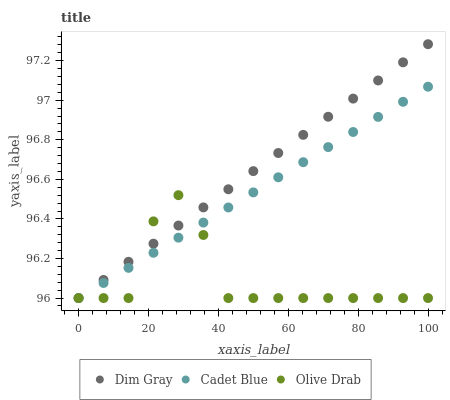Does Olive Drab have the minimum area under the curve?
Answer yes or no. Yes. Does Dim Gray have the maximum area under the curve?
Answer yes or no. Yes. Does Dim Gray have the minimum area under the curve?
Answer yes or no. No. Does Olive Drab have the maximum area under the curve?
Answer yes or no. No. Is Dim Gray the smoothest?
Answer yes or no. Yes. Is Olive Drab the roughest?
Answer yes or no. Yes. Is Olive Drab the smoothest?
Answer yes or no. No. Is Dim Gray the roughest?
Answer yes or no. No. Does Cadet Blue have the lowest value?
Answer yes or no. Yes. Does Dim Gray have the highest value?
Answer yes or no. Yes. Does Olive Drab have the highest value?
Answer yes or no. No. Does Dim Gray intersect Olive Drab?
Answer yes or no. Yes. Is Dim Gray less than Olive Drab?
Answer yes or no. No. Is Dim Gray greater than Olive Drab?
Answer yes or no. No. 